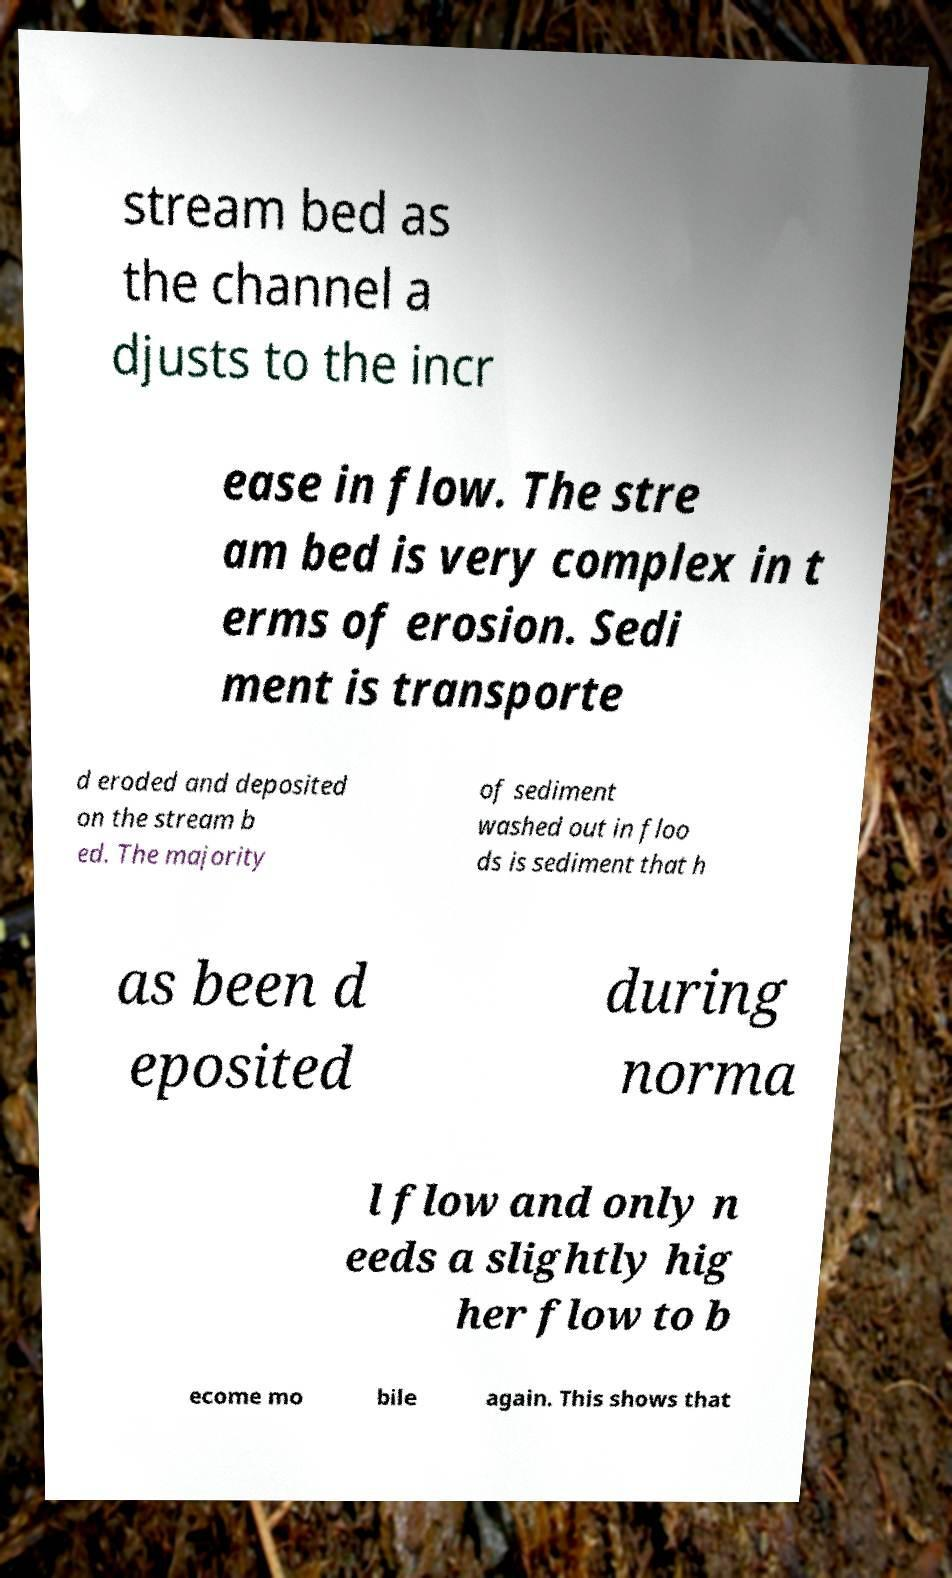Can you accurately transcribe the text from the provided image for me? stream bed as the channel a djusts to the incr ease in flow. The stre am bed is very complex in t erms of erosion. Sedi ment is transporte d eroded and deposited on the stream b ed. The majority of sediment washed out in floo ds is sediment that h as been d eposited during norma l flow and only n eeds a slightly hig her flow to b ecome mo bile again. This shows that 